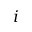<formula> <loc_0><loc_0><loc_500><loc_500>i</formula> 